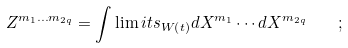<formula> <loc_0><loc_0><loc_500><loc_500>Z ^ { m _ { 1 } \dots m _ { 2 q } } = \int \lim i t s _ { W \left ( t \right ) } d X ^ { m _ { 1 } } \cdots d X ^ { m _ { 2 q } } \quad ;</formula> 